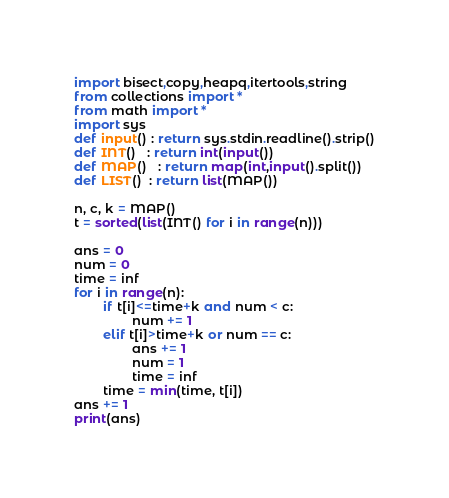<code> <loc_0><loc_0><loc_500><loc_500><_Python_>import bisect,copy,heapq,itertools,string
from collections import *
from math import *
import sys
def input() : return sys.stdin.readline().strip()
def INT()   : return int(input())
def MAP()   : return map(int,input().split())
def LIST()  : return list(MAP())

n, c, k = MAP()
t = sorted(list(INT() for i in range(n)))

ans = 0
num = 0
time = inf
for i in range(n):
        if t[i]<=time+k and num < c:
                num += 1
        elif t[i]>time+k or num == c:
                ans += 1
                num = 1
                time = inf
        time = min(time, t[i])
ans += 1
print(ans)</code> 